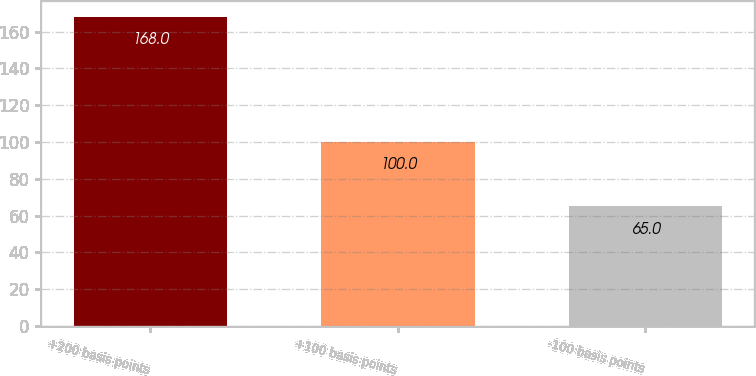Convert chart. <chart><loc_0><loc_0><loc_500><loc_500><bar_chart><fcel>+200 basis points<fcel>+100 basis points<fcel>-100 basis points<nl><fcel>168<fcel>100<fcel>65<nl></chart> 